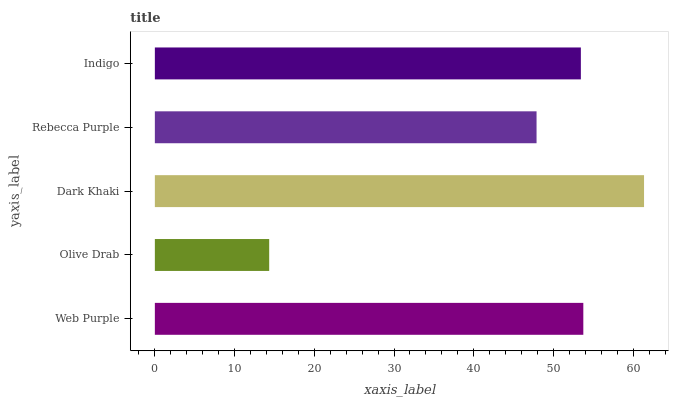Is Olive Drab the minimum?
Answer yes or no. Yes. Is Dark Khaki the maximum?
Answer yes or no. Yes. Is Dark Khaki the minimum?
Answer yes or no. No. Is Olive Drab the maximum?
Answer yes or no. No. Is Dark Khaki greater than Olive Drab?
Answer yes or no. Yes. Is Olive Drab less than Dark Khaki?
Answer yes or no. Yes. Is Olive Drab greater than Dark Khaki?
Answer yes or no. No. Is Dark Khaki less than Olive Drab?
Answer yes or no. No. Is Indigo the high median?
Answer yes or no. Yes. Is Indigo the low median?
Answer yes or no. Yes. Is Dark Khaki the high median?
Answer yes or no. No. Is Web Purple the low median?
Answer yes or no. No. 